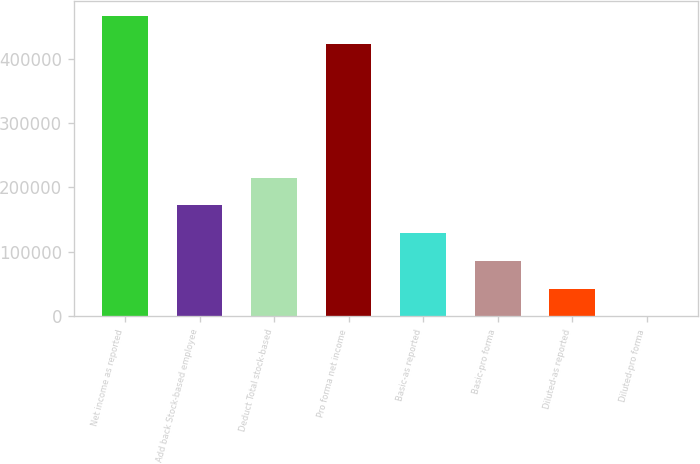Convert chart. <chart><loc_0><loc_0><loc_500><loc_500><bar_chart><fcel>Net income as reported<fcel>Add back Stock-based employee<fcel>Deduct Total stock-based<fcel>Pro forma net income<fcel>Basic-as reported<fcel>Basic-pro forma<fcel>Diluted-as reported<fcel>Diluted-pro forma<nl><fcel>466076<fcel>172165<fcel>215207<fcel>423035<fcel>129124<fcel>86083.3<fcel>43042.2<fcel>1.1<nl></chart> 